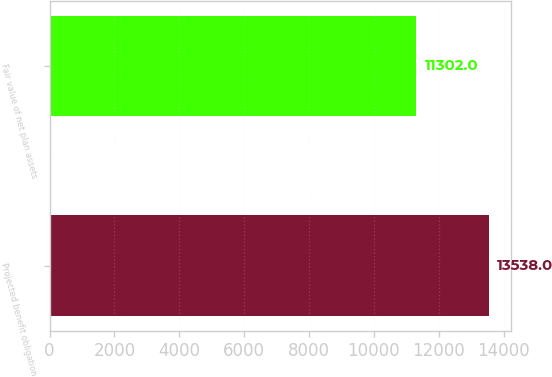Convert chart. <chart><loc_0><loc_0><loc_500><loc_500><bar_chart><fcel>Projected benefit obligation<fcel>Fair value of net plan assets<nl><fcel>13538<fcel>11302<nl></chart> 